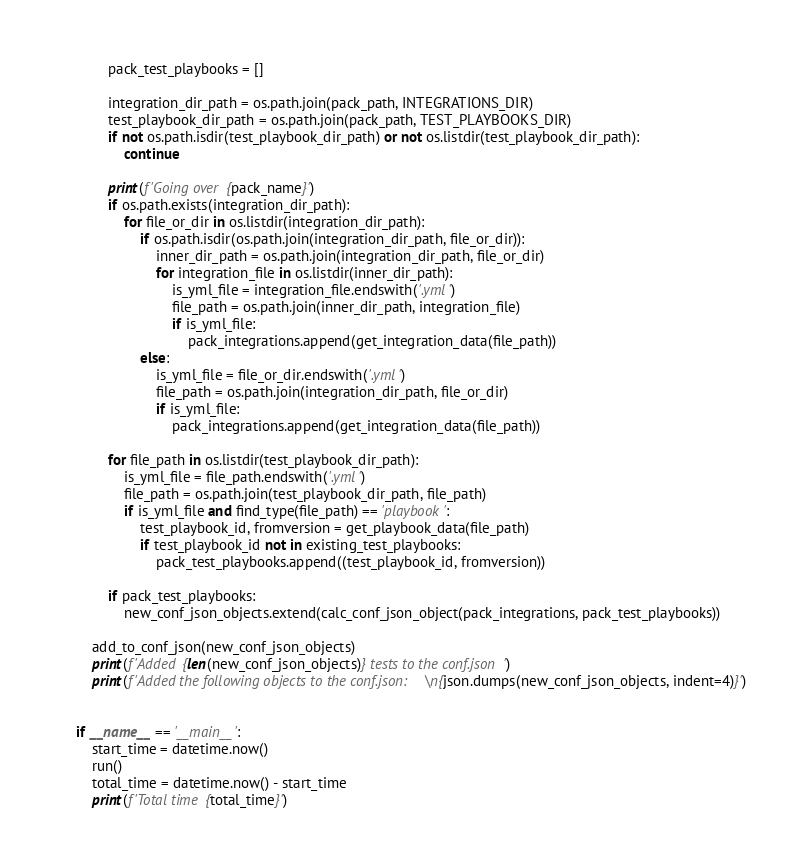Convert code to text. <code><loc_0><loc_0><loc_500><loc_500><_Python_>        pack_test_playbooks = []

        integration_dir_path = os.path.join(pack_path, INTEGRATIONS_DIR)
        test_playbook_dir_path = os.path.join(pack_path, TEST_PLAYBOOKS_DIR)
        if not os.path.isdir(test_playbook_dir_path) or not os.listdir(test_playbook_dir_path):
            continue

        print(f'Going over {pack_name}')
        if os.path.exists(integration_dir_path):
            for file_or_dir in os.listdir(integration_dir_path):
                if os.path.isdir(os.path.join(integration_dir_path, file_or_dir)):
                    inner_dir_path = os.path.join(integration_dir_path, file_or_dir)
                    for integration_file in os.listdir(inner_dir_path):
                        is_yml_file = integration_file.endswith('.yml')
                        file_path = os.path.join(inner_dir_path, integration_file)
                        if is_yml_file:
                            pack_integrations.append(get_integration_data(file_path))
                else:
                    is_yml_file = file_or_dir.endswith('.yml')
                    file_path = os.path.join(integration_dir_path, file_or_dir)
                    if is_yml_file:
                        pack_integrations.append(get_integration_data(file_path))

        for file_path in os.listdir(test_playbook_dir_path):
            is_yml_file = file_path.endswith('.yml')
            file_path = os.path.join(test_playbook_dir_path, file_path)
            if is_yml_file and find_type(file_path) == 'playbook':
                test_playbook_id, fromversion = get_playbook_data(file_path)
                if test_playbook_id not in existing_test_playbooks:
                    pack_test_playbooks.append((test_playbook_id, fromversion))

        if pack_test_playbooks:
            new_conf_json_objects.extend(calc_conf_json_object(pack_integrations, pack_test_playbooks))

    add_to_conf_json(new_conf_json_objects)
    print(f'Added {len(new_conf_json_objects)} tests to the conf.json')
    print(f'Added the following objects to the conf.json:\n{json.dumps(new_conf_json_objects, indent=4)}')


if __name__ == '__main__':
    start_time = datetime.now()
    run()
    total_time = datetime.now() - start_time
    print(f'Total time {total_time}')
</code> 